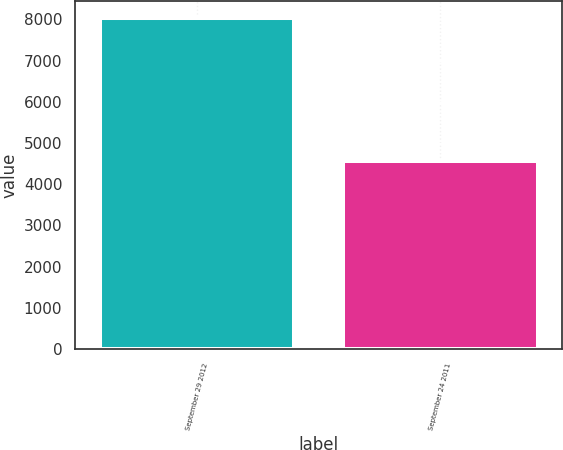Convert chart to OTSL. <chart><loc_0><loc_0><loc_500><loc_500><bar_chart><fcel>September 29 2012<fcel>September 24 2011<nl><fcel>8034<fcel>4574<nl></chart> 